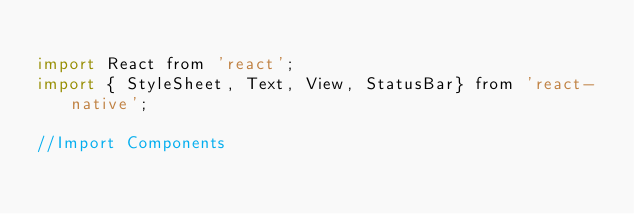<code> <loc_0><loc_0><loc_500><loc_500><_JavaScript_>
import React from 'react';
import { StyleSheet, Text, View, StatusBar} from 'react-native';

//Import Components </code> 